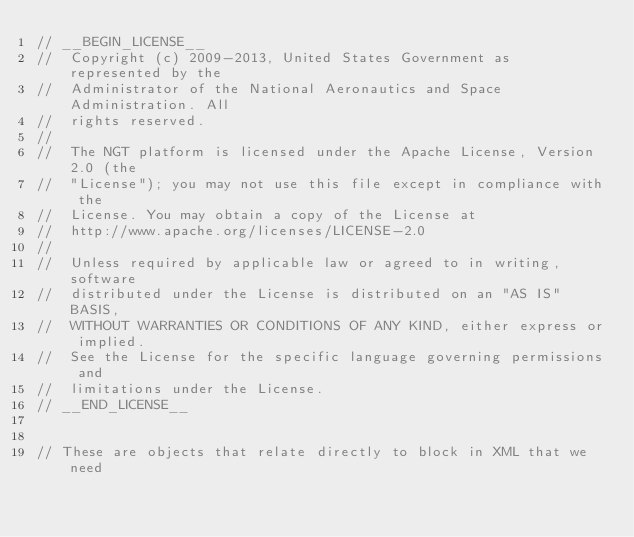Convert code to text. <code><loc_0><loc_0><loc_500><loc_500><_C_>// __BEGIN_LICENSE__
//  Copyright (c) 2009-2013, United States Government as represented by the
//  Administrator of the National Aeronautics and Space Administration. All
//  rights reserved.
//
//  The NGT platform is licensed under the Apache License, Version 2.0 (the
//  "License"); you may not use this file except in compliance with the
//  License. You may obtain a copy of the License at
//  http://www.apache.org/licenses/LICENSE-2.0
//
//  Unless required by applicable law or agreed to in writing, software
//  distributed under the License is distributed on an "AS IS" BASIS,
//  WITHOUT WARRANTIES OR CONDITIONS OF ANY KIND, either express or implied.
//  See the License for the specific language governing permissions and
//  limitations under the License.
// __END_LICENSE__


// These are objects that relate directly to block in XML that we need</code> 